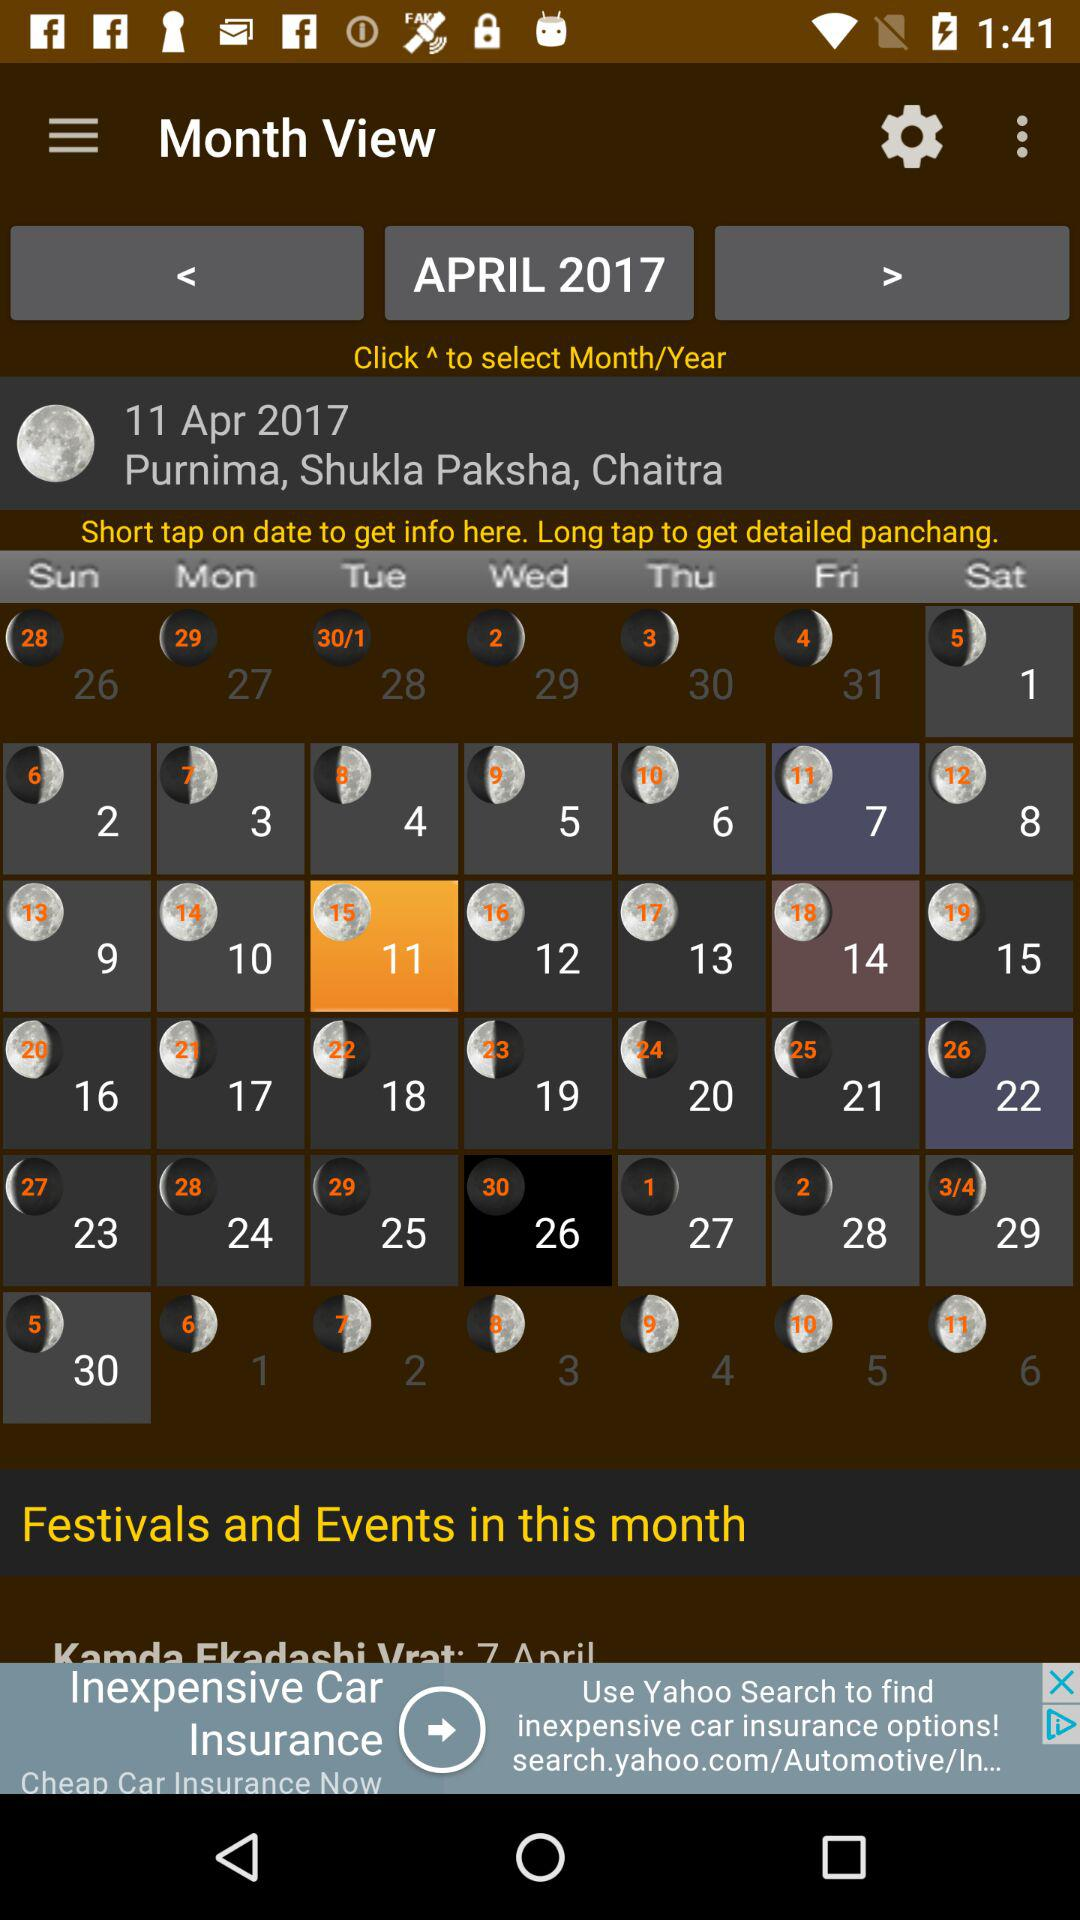When is the Purnima of Chaitra Shukla Paksha? Purnima is on April 11, 2017. 